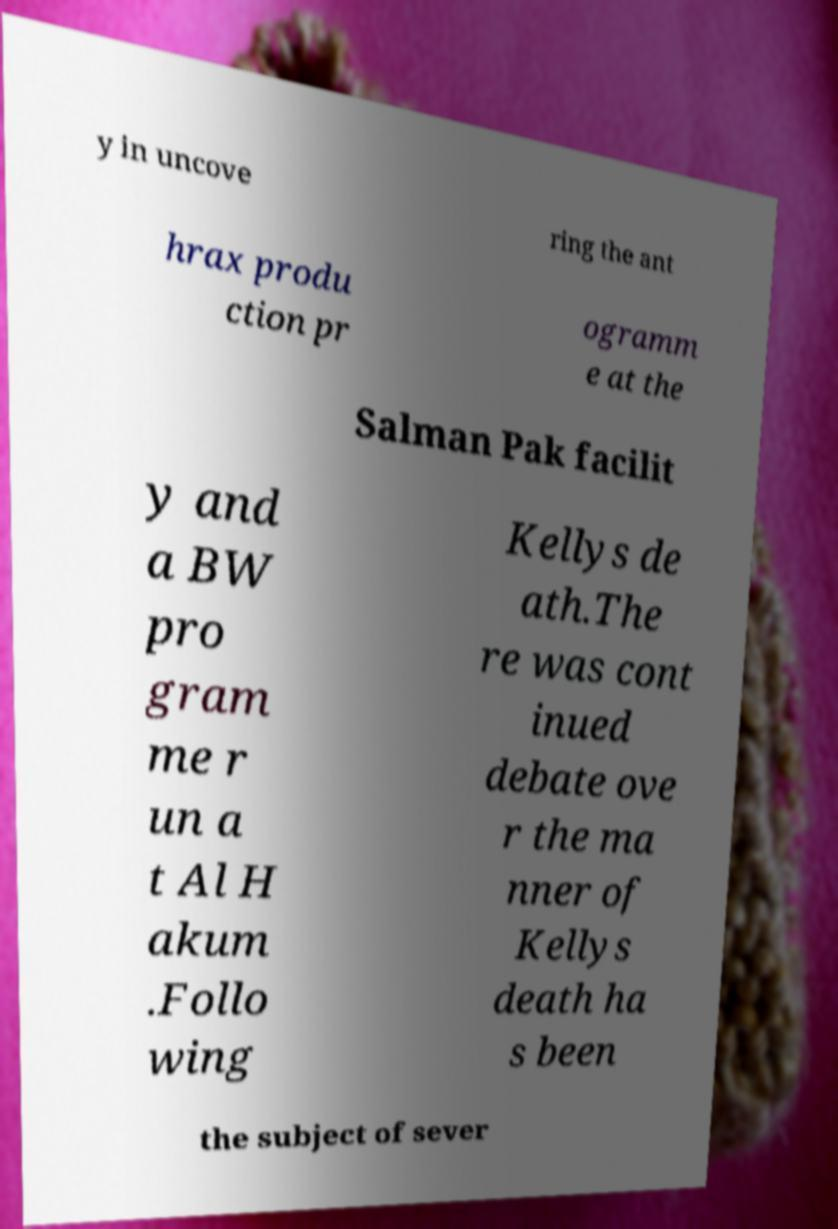I need the written content from this picture converted into text. Can you do that? y in uncove ring the ant hrax produ ction pr ogramm e at the Salman Pak facilit y and a BW pro gram me r un a t Al H akum .Follo wing Kellys de ath.The re was cont inued debate ove r the ma nner of Kellys death ha s been the subject of sever 